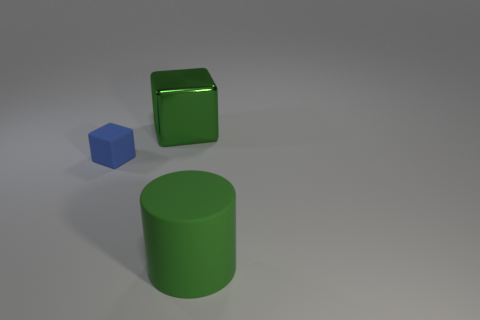Add 3 big cubes. How many objects exist? 6 Subtract all cylinders. How many objects are left? 2 Add 3 tiny yellow matte objects. How many tiny yellow matte objects exist? 3 Subtract 0 yellow spheres. How many objects are left? 3 Subtract all large yellow matte blocks. Subtract all matte objects. How many objects are left? 1 Add 1 green rubber objects. How many green rubber objects are left? 2 